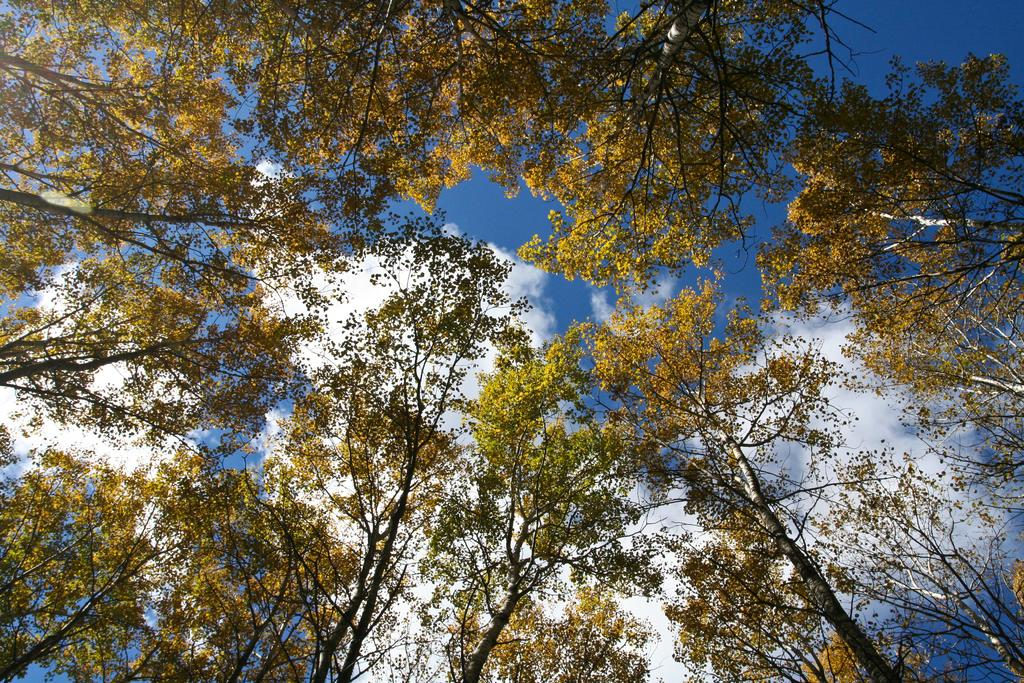What type of vegetation is present in the front of the image? There are trees in the front of the image. What can be seen in the background of the image? The sky is visible in the background of the image. How would you describe the sky in the image? The sky appears to be cloudy. What type of lace can be seen hanging from the trees in the image? There is no lace present in the image; it features trees and a cloudy sky. How does the light affect the appearance of the bean in the image? There is no bean present in the image, so the effect of light on its appearance cannot be determined. 